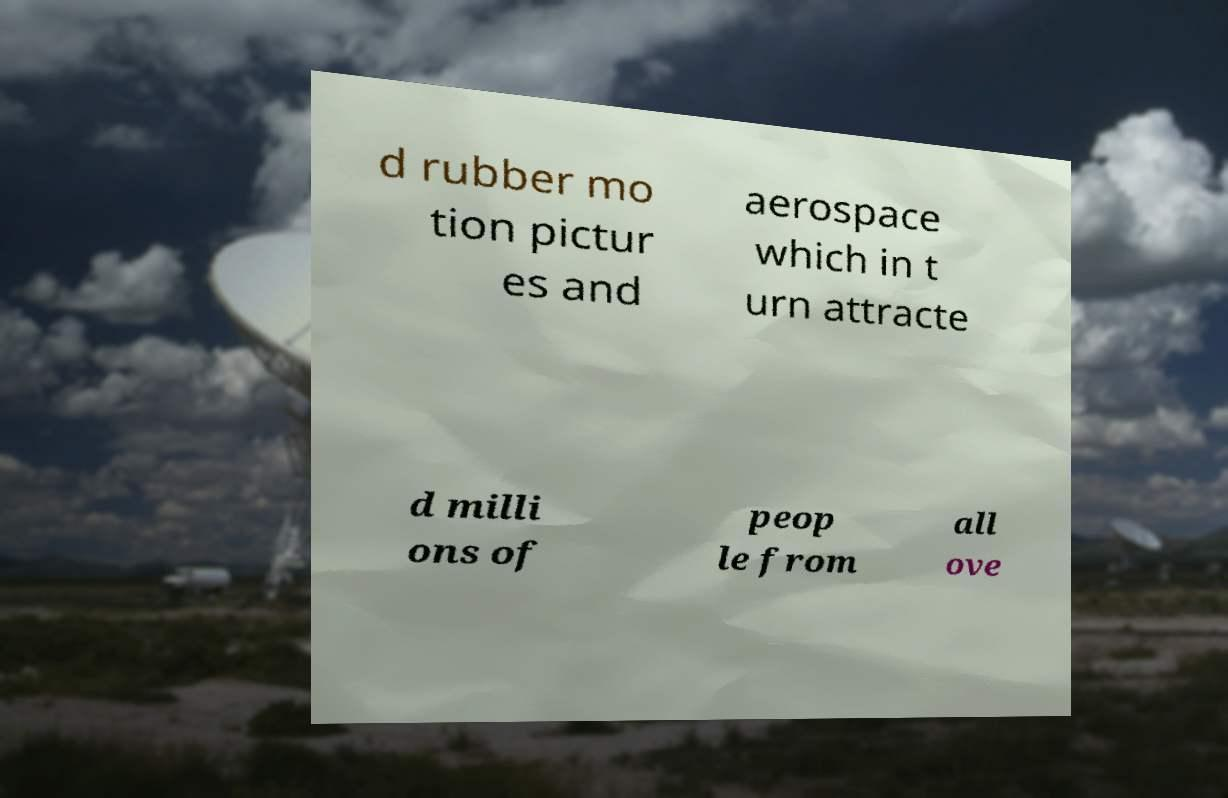Can you accurately transcribe the text from the provided image for me? d rubber mo tion pictur es and aerospace which in t urn attracte d milli ons of peop le from all ove 